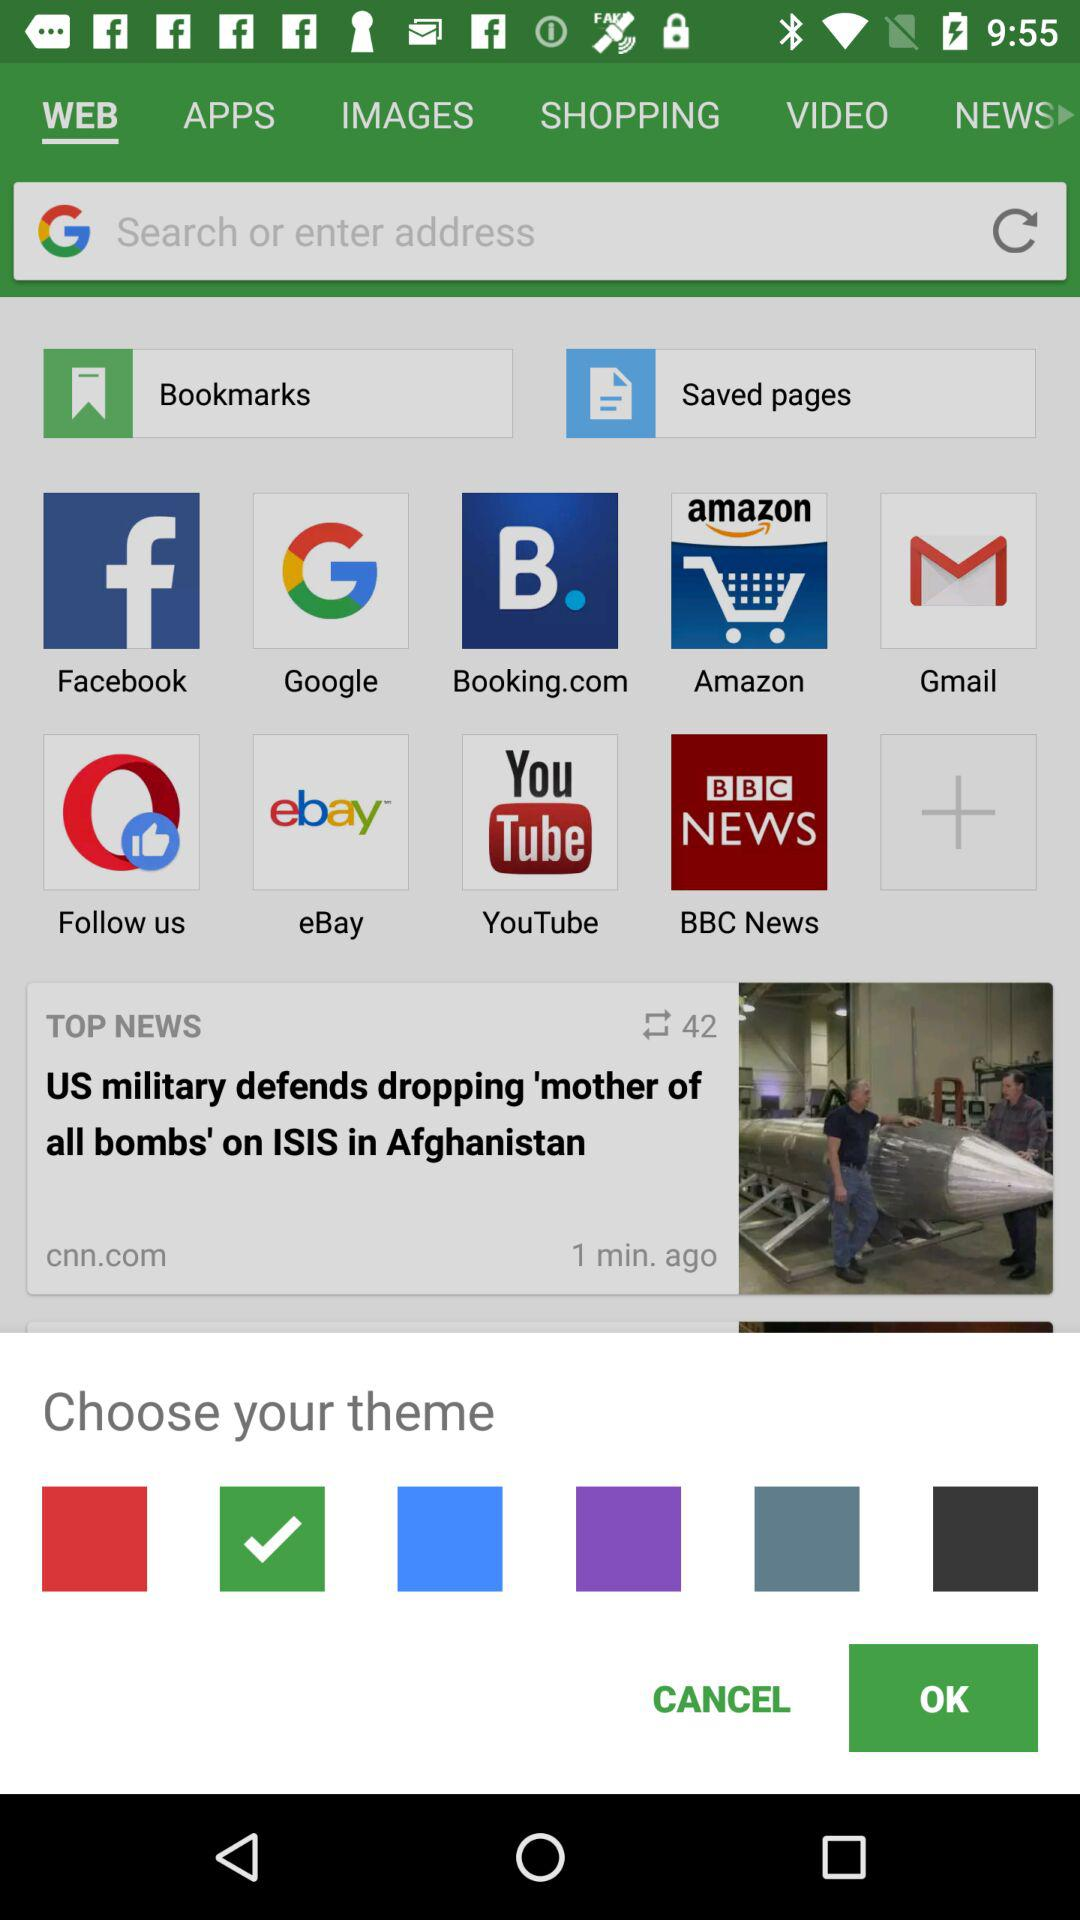How many colors are there in the theme selection?
Answer the question using a single word or phrase. 6 